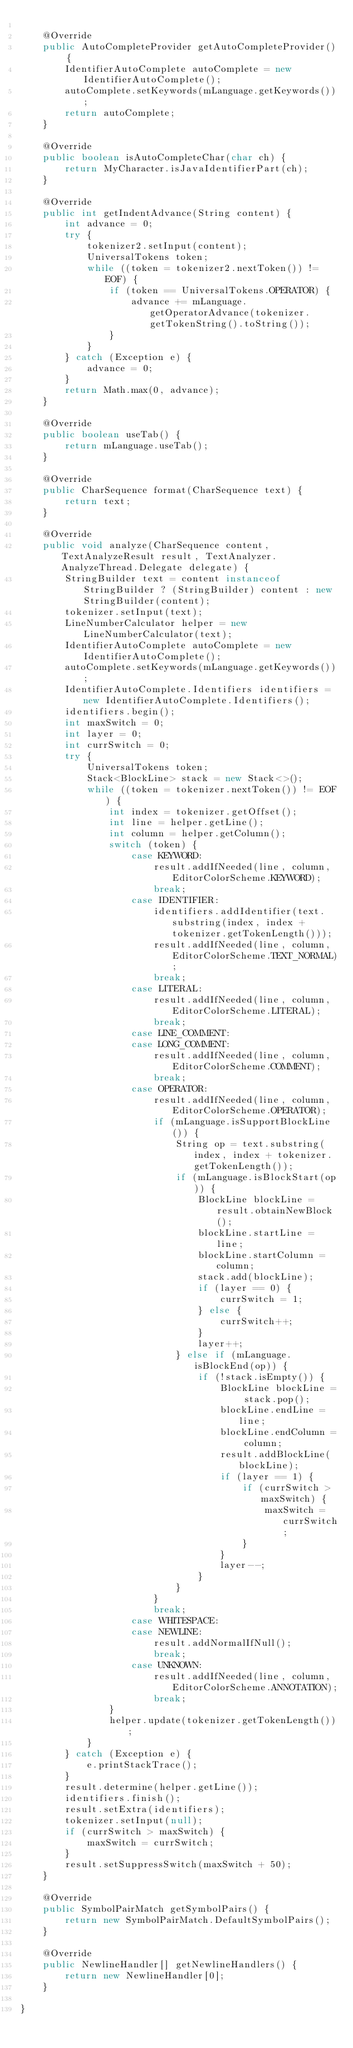Convert code to text. <code><loc_0><loc_0><loc_500><loc_500><_Java_>
    @Override
    public AutoCompleteProvider getAutoCompleteProvider() {
        IdentifierAutoComplete autoComplete = new IdentifierAutoComplete();
        autoComplete.setKeywords(mLanguage.getKeywords());
        return autoComplete;
    }

    @Override
    public boolean isAutoCompleteChar(char ch) {
        return MyCharacter.isJavaIdentifierPart(ch);
    }

    @Override
    public int getIndentAdvance(String content) {
        int advance = 0;
        try {
            tokenizer2.setInput(content);
            UniversalTokens token;
            while ((token = tokenizer2.nextToken()) != EOF) {
                if (token == UniversalTokens.OPERATOR) {
                    advance += mLanguage.getOperatorAdvance(tokenizer.getTokenString().toString());
                }
            }
        } catch (Exception e) {
            advance = 0;
        }
        return Math.max(0, advance);
    }

    @Override
    public boolean useTab() {
        return mLanguage.useTab();
    }

    @Override
    public CharSequence format(CharSequence text) {
        return text;
    }

    @Override
    public void analyze(CharSequence content, TextAnalyzeResult result, TextAnalyzer.AnalyzeThread.Delegate delegate) {
        StringBuilder text = content instanceof StringBuilder ? (StringBuilder) content : new StringBuilder(content);
        tokenizer.setInput(text);
        LineNumberCalculator helper = new LineNumberCalculator(text);
        IdentifierAutoComplete autoComplete = new IdentifierAutoComplete();
        autoComplete.setKeywords(mLanguage.getKeywords());
        IdentifierAutoComplete.Identifiers identifiers = new IdentifierAutoComplete.Identifiers();
        identifiers.begin();
        int maxSwitch = 0;
        int layer = 0;
        int currSwitch = 0;
        try {
            UniversalTokens token;
            Stack<BlockLine> stack = new Stack<>();
            while ((token = tokenizer.nextToken()) != EOF) {
                int index = tokenizer.getOffset();
                int line = helper.getLine();
                int column = helper.getColumn();
                switch (token) {
                    case KEYWORD:
                        result.addIfNeeded(line, column, EditorColorScheme.KEYWORD);
                        break;
                    case IDENTIFIER:
                        identifiers.addIdentifier(text.substring(index, index + tokenizer.getTokenLength()));
                        result.addIfNeeded(line, column, EditorColorScheme.TEXT_NORMAL);
                        break;
                    case LITERAL:
                        result.addIfNeeded(line, column, EditorColorScheme.LITERAL);
                        break;
                    case LINE_COMMENT:
                    case LONG_COMMENT:
                        result.addIfNeeded(line, column, EditorColorScheme.COMMENT);
                        break;
                    case OPERATOR:
                        result.addIfNeeded(line, column, EditorColorScheme.OPERATOR);
                        if (mLanguage.isSupportBlockLine()) {
                            String op = text.substring(index, index + tokenizer.getTokenLength());
                            if (mLanguage.isBlockStart(op)) {
                                BlockLine blockLine = result.obtainNewBlock();
                                blockLine.startLine = line;
                                blockLine.startColumn = column;
                                stack.add(blockLine);
                                if (layer == 0) {
                                    currSwitch = 1;
                                } else {
                                    currSwitch++;
                                }
                                layer++;
                            } else if (mLanguage.isBlockEnd(op)) {
                                if (!stack.isEmpty()) {
                                    BlockLine blockLine = stack.pop();
                                    blockLine.endLine = line;
                                    blockLine.endColumn = column;
                                    result.addBlockLine(blockLine);
                                    if (layer == 1) {
                                        if (currSwitch > maxSwitch) {
                                            maxSwitch = currSwitch;
                                        }
                                    }
                                    layer--;
                                }
                            }
                        }
                        break;
                    case WHITESPACE:
                    case NEWLINE:
                        result.addNormalIfNull();
                        break;
                    case UNKNOWN:
                        result.addIfNeeded(line, column, EditorColorScheme.ANNOTATION);
                        break;
                }
                helper.update(tokenizer.getTokenLength());
            }
        } catch (Exception e) {
            e.printStackTrace();
        }
        result.determine(helper.getLine());
        identifiers.finish();
        result.setExtra(identifiers);
        tokenizer.setInput(null);
        if (currSwitch > maxSwitch) {
            maxSwitch = currSwitch;
        }
        result.setSuppressSwitch(maxSwitch + 50);
    }

    @Override
    public SymbolPairMatch getSymbolPairs() {
        return new SymbolPairMatch.DefaultSymbolPairs();
    }

    @Override
    public NewlineHandler[] getNewlineHandlers() {
        return new NewlineHandler[0];
    }

}
</code> 